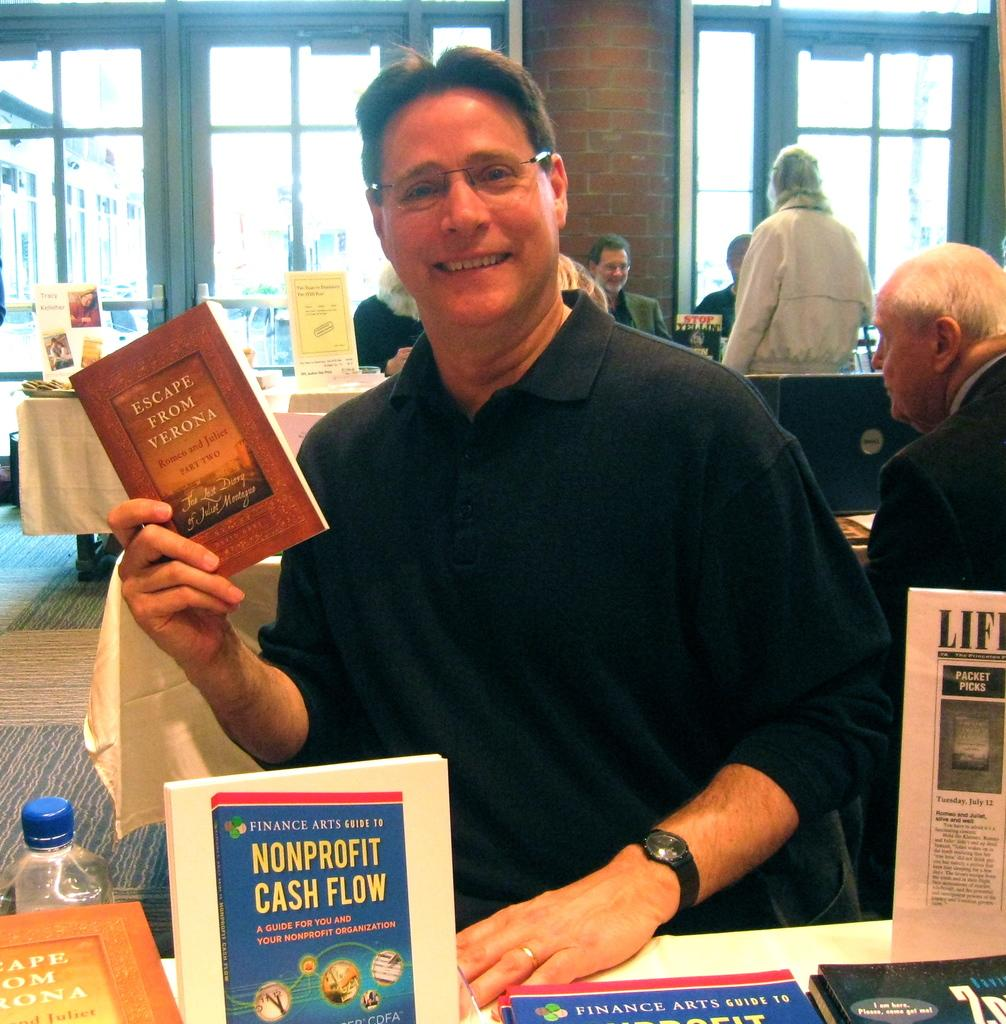Provide a one-sentence caption for the provided image. Man in front of some books while holding a book called "Escape From Verona". 